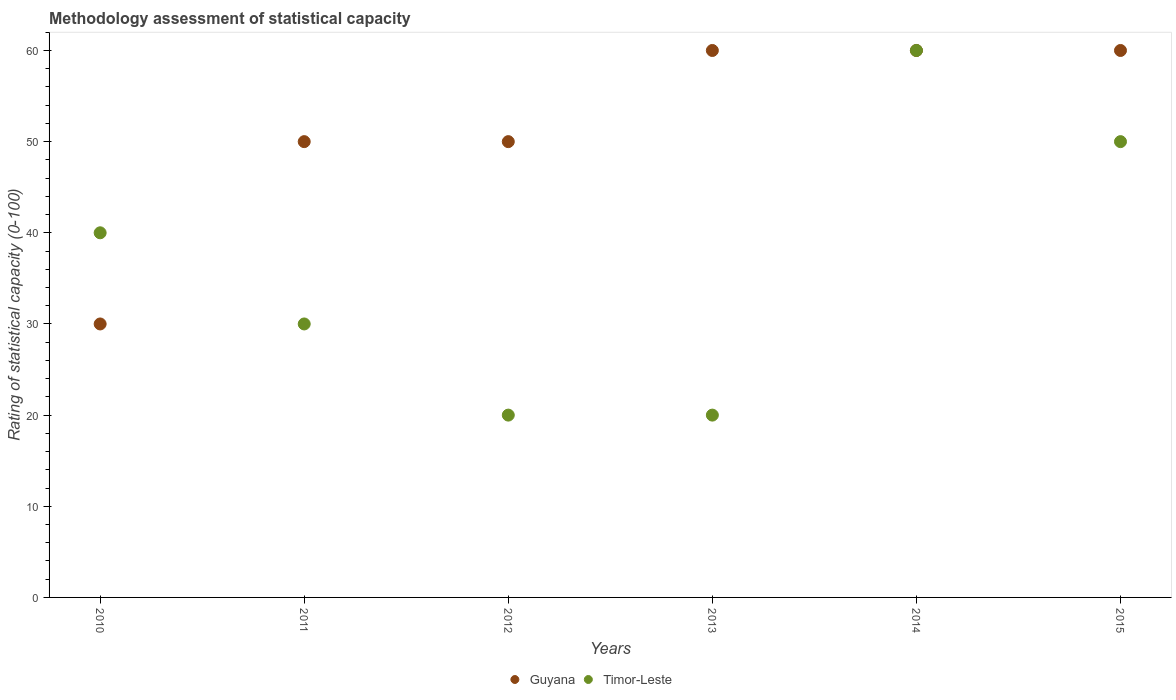How many different coloured dotlines are there?
Your answer should be very brief. 2. Is the number of dotlines equal to the number of legend labels?
Offer a very short reply. Yes. Across all years, what is the maximum rating of statistical capacity in Timor-Leste?
Offer a terse response. 60. In which year was the rating of statistical capacity in Guyana maximum?
Ensure brevity in your answer.  2013. What is the total rating of statistical capacity in Guyana in the graph?
Your response must be concise. 310. What is the difference between the rating of statistical capacity in Timor-Leste in 2015 and the rating of statistical capacity in Guyana in 2010?
Offer a terse response. 20. What is the average rating of statistical capacity in Timor-Leste per year?
Give a very brief answer. 36.67. In the year 2012, what is the difference between the rating of statistical capacity in Timor-Leste and rating of statistical capacity in Guyana?
Your answer should be compact. -30. In how many years, is the rating of statistical capacity in Guyana greater than 36?
Keep it short and to the point. 5. What is the ratio of the rating of statistical capacity in Timor-Leste in 2011 to that in 2012?
Your response must be concise. 1.5. Is the rating of statistical capacity in Guyana in 2011 less than that in 2013?
Your response must be concise. Yes. Is the difference between the rating of statistical capacity in Timor-Leste in 2011 and 2013 greater than the difference between the rating of statistical capacity in Guyana in 2011 and 2013?
Offer a very short reply. Yes. What is the difference between the highest and the second highest rating of statistical capacity in Guyana?
Your answer should be very brief. 0. What is the difference between the highest and the lowest rating of statistical capacity in Timor-Leste?
Provide a succinct answer. 40. In how many years, is the rating of statistical capacity in Timor-Leste greater than the average rating of statistical capacity in Timor-Leste taken over all years?
Offer a very short reply. 3. Is the sum of the rating of statistical capacity in Timor-Leste in 2012 and 2014 greater than the maximum rating of statistical capacity in Guyana across all years?
Ensure brevity in your answer.  Yes. Is the rating of statistical capacity in Guyana strictly greater than the rating of statistical capacity in Timor-Leste over the years?
Offer a terse response. No. Is the rating of statistical capacity in Timor-Leste strictly less than the rating of statistical capacity in Guyana over the years?
Your answer should be compact. No. How many dotlines are there?
Provide a short and direct response. 2. Are the values on the major ticks of Y-axis written in scientific E-notation?
Offer a very short reply. No. Does the graph contain any zero values?
Ensure brevity in your answer.  No. Does the graph contain grids?
Give a very brief answer. No. Where does the legend appear in the graph?
Provide a succinct answer. Bottom center. What is the title of the graph?
Provide a short and direct response. Methodology assessment of statistical capacity. Does "Uganda" appear as one of the legend labels in the graph?
Offer a very short reply. No. What is the label or title of the X-axis?
Offer a terse response. Years. What is the label or title of the Y-axis?
Make the answer very short. Rating of statistical capacity (0-100). What is the Rating of statistical capacity (0-100) in Guyana in 2010?
Your answer should be compact. 30. What is the Rating of statistical capacity (0-100) in Timor-Leste in 2010?
Your answer should be compact. 40. What is the Rating of statistical capacity (0-100) of Guyana in 2011?
Keep it short and to the point. 50. What is the Rating of statistical capacity (0-100) in Timor-Leste in 2011?
Your response must be concise. 30. What is the Rating of statistical capacity (0-100) of Guyana in 2012?
Keep it short and to the point. 50. What is the Rating of statistical capacity (0-100) of Guyana in 2013?
Provide a succinct answer. 60. What is the Rating of statistical capacity (0-100) of Timor-Leste in 2013?
Provide a short and direct response. 20. What is the Rating of statistical capacity (0-100) in Timor-Leste in 2014?
Offer a terse response. 60. What is the Rating of statistical capacity (0-100) in Guyana in 2015?
Provide a short and direct response. 60. Across all years, what is the maximum Rating of statistical capacity (0-100) in Guyana?
Your response must be concise. 60. Across all years, what is the maximum Rating of statistical capacity (0-100) in Timor-Leste?
Make the answer very short. 60. Across all years, what is the minimum Rating of statistical capacity (0-100) of Timor-Leste?
Your answer should be very brief. 20. What is the total Rating of statistical capacity (0-100) of Guyana in the graph?
Provide a short and direct response. 310. What is the total Rating of statistical capacity (0-100) in Timor-Leste in the graph?
Offer a terse response. 220. What is the difference between the Rating of statistical capacity (0-100) of Guyana in 2010 and that in 2012?
Ensure brevity in your answer.  -20. What is the difference between the Rating of statistical capacity (0-100) in Timor-Leste in 2010 and that in 2012?
Offer a terse response. 20. What is the difference between the Rating of statistical capacity (0-100) in Guyana in 2010 and that in 2015?
Keep it short and to the point. -30. What is the difference between the Rating of statistical capacity (0-100) in Timor-Leste in 2010 and that in 2015?
Provide a short and direct response. -10. What is the difference between the Rating of statistical capacity (0-100) of Guyana in 2011 and that in 2012?
Make the answer very short. 0. What is the difference between the Rating of statistical capacity (0-100) of Timor-Leste in 2011 and that in 2012?
Your response must be concise. 10. What is the difference between the Rating of statistical capacity (0-100) of Guyana in 2011 and that in 2013?
Keep it short and to the point. -10. What is the difference between the Rating of statistical capacity (0-100) of Timor-Leste in 2011 and that in 2013?
Keep it short and to the point. 10. What is the difference between the Rating of statistical capacity (0-100) of Guyana in 2011 and that in 2014?
Keep it short and to the point. -10. What is the difference between the Rating of statistical capacity (0-100) in Timor-Leste in 2011 and that in 2014?
Your answer should be very brief. -30. What is the difference between the Rating of statistical capacity (0-100) in Guyana in 2011 and that in 2015?
Your answer should be compact. -10. What is the difference between the Rating of statistical capacity (0-100) in Timor-Leste in 2011 and that in 2015?
Your answer should be very brief. -20. What is the difference between the Rating of statistical capacity (0-100) of Guyana in 2012 and that in 2014?
Your answer should be very brief. -10. What is the difference between the Rating of statistical capacity (0-100) in Timor-Leste in 2012 and that in 2015?
Your response must be concise. -30. What is the difference between the Rating of statistical capacity (0-100) in Timor-Leste in 2013 and that in 2014?
Offer a terse response. -40. What is the difference between the Rating of statistical capacity (0-100) in Timor-Leste in 2013 and that in 2015?
Ensure brevity in your answer.  -30. What is the difference between the Rating of statistical capacity (0-100) of Guyana in 2014 and that in 2015?
Provide a short and direct response. 0. What is the difference between the Rating of statistical capacity (0-100) in Guyana in 2010 and the Rating of statistical capacity (0-100) in Timor-Leste in 2014?
Make the answer very short. -30. What is the difference between the Rating of statistical capacity (0-100) in Guyana in 2011 and the Rating of statistical capacity (0-100) in Timor-Leste in 2012?
Give a very brief answer. 30. What is the difference between the Rating of statistical capacity (0-100) in Guyana in 2011 and the Rating of statistical capacity (0-100) in Timor-Leste in 2014?
Provide a succinct answer. -10. What is the difference between the Rating of statistical capacity (0-100) in Guyana in 2012 and the Rating of statistical capacity (0-100) in Timor-Leste in 2014?
Your answer should be very brief. -10. What is the difference between the Rating of statistical capacity (0-100) in Guyana in 2012 and the Rating of statistical capacity (0-100) in Timor-Leste in 2015?
Offer a terse response. 0. What is the difference between the Rating of statistical capacity (0-100) of Guyana in 2013 and the Rating of statistical capacity (0-100) of Timor-Leste in 2014?
Offer a terse response. 0. What is the average Rating of statistical capacity (0-100) of Guyana per year?
Offer a very short reply. 51.67. What is the average Rating of statistical capacity (0-100) of Timor-Leste per year?
Offer a very short reply. 36.67. In the year 2013, what is the difference between the Rating of statistical capacity (0-100) of Guyana and Rating of statistical capacity (0-100) of Timor-Leste?
Your answer should be compact. 40. In the year 2015, what is the difference between the Rating of statistical capacity (0-100) in Guyana and Rating of statistical capacity (0-100) in Timor-Leste?
Make the answer very short. 10. What is the ratio of the Rating of statistical capacity (0-100) in Timor-Leste in 2010 to that in 2011?
Your answer should be very brief. 1.33. What is the ratio of the Rating of statistical capacity (0-100) in Timor-Leste in 2010 to that in 2013?
Your answer should be compact. 2. What is the ratio of the Rating of statistical capacity (0-100) in Guyana in 2010 to that in 2014?
Give a very brief answer. 0.5. What is the ratio of the Rating of statistical capacity (0-100) of Timor-Leste in 2010 to that in 2014?
Make the answer very short. 0.67. What is the ratio of the Rating of statistical capacity (0-100) of Timor-Leste in 2010 to that in 2015?
Provide a succinct answer. 0.8. What is the ratio of the Rating of statistical capacity (0-100) of Guyana in 2011 to that in 2013?
Ensure brevity in your answer.  0.83. What is the ratio of the Rating of statistical capacity (0-100) in Timor-Leste in 2011 to that in 2013?
Keep it short and to the point. 1.5. What is the ratio of the Rating of statistical capacity (0-100) in Guyana in 2011 to that in 2015?
Your response must be concise. 0.83. What is the ratio of the Rating of statistical capacity (0-100) in Guyana in 2012 to that in 2013?
Your response must be concise. 0.83. What is the ratio of the Rating of statistical capacity (0-100) of Timor-Leste in 2012 to that in 2013?
Provide a short and direct response. 1. What is the ratio of the Rating of statistical capacity (0-100) in Guyana in 2012 to that in 2014?
Your answer should be very brief. 0.83. What is the ratio of the Rating of statistical capacity (0-100) of Guyana in 2013 to that in 2014?
Provide a succinct answer. 1. What is the ratio of the Rating of statistical capacity (0-100) in Timor-Leste in 2013 to that in 2014?
Ensure brevity in your answer.  0.33. What is the ratio of the Rating of statistical capacity (0-100) of Guyana in 2014 to that in 2015?
Offer a terse response. 1. What is the difference between the highest and the lowest Rating of statistical capacity (0-100) of Guyana?
Your answer should be very brief. 30. What is the difference between the highest and the lowest Rating of statistical capacity (0-100) in Timor-Leste?
Offer a very short reply. 40. 